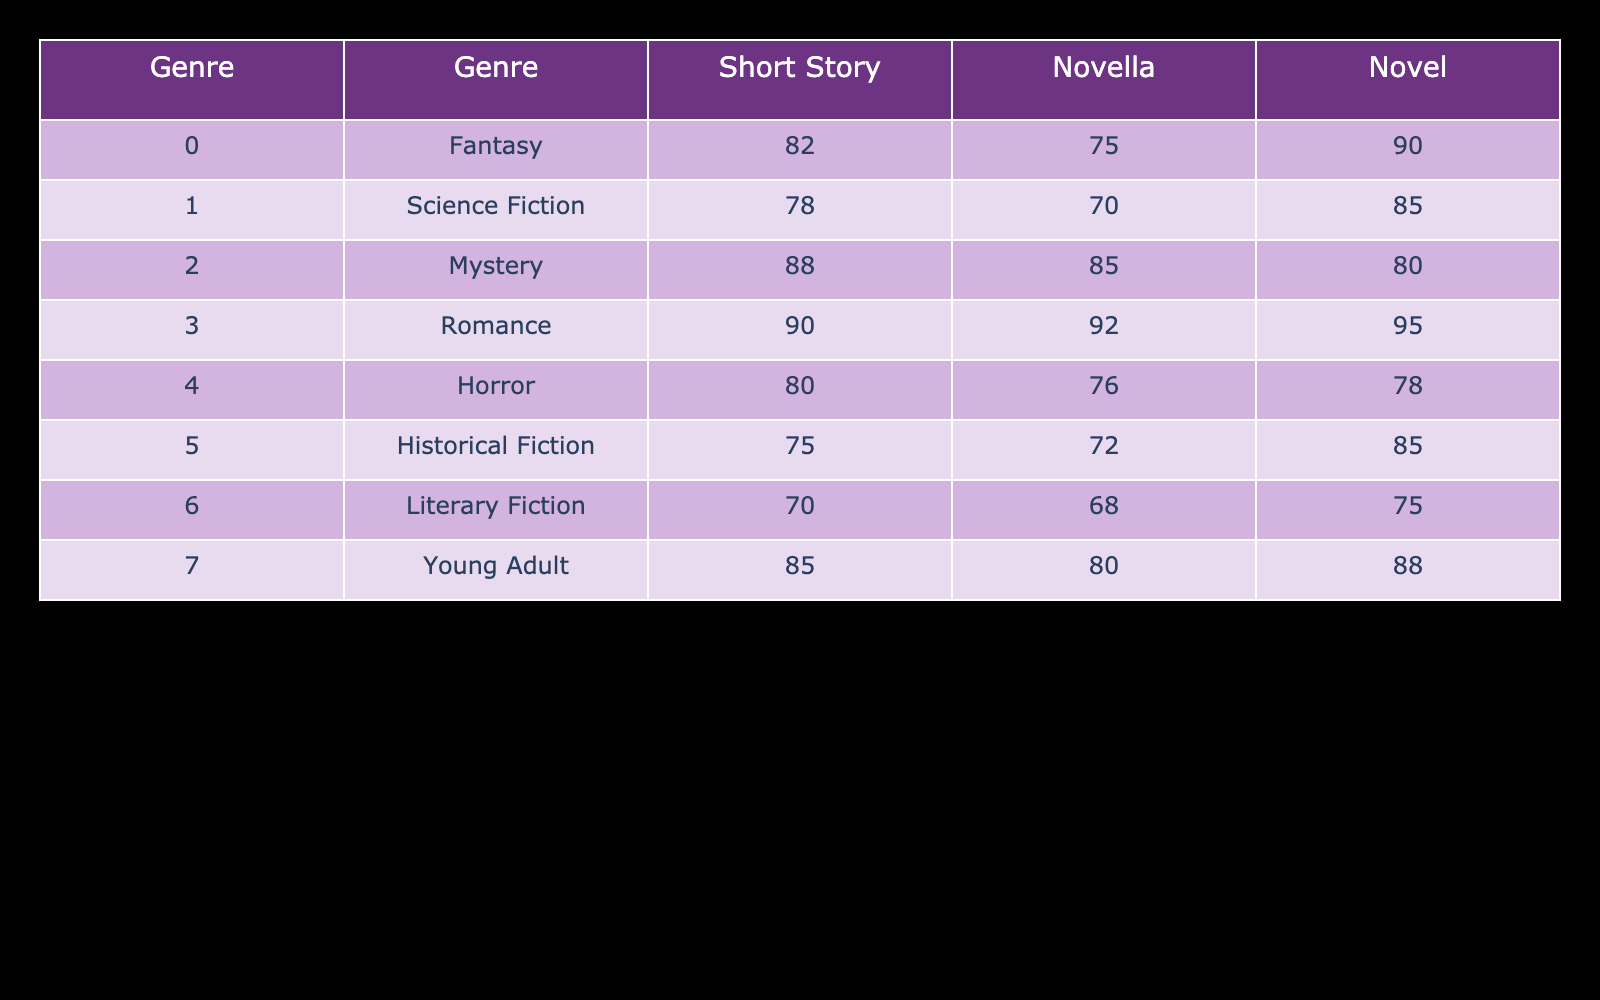What is the highest engagement level for the Romance genre? The table shows that for the Romance genre, the highest engagement level is 95 for Novels.
Answer: 95 Which story format has the lowest engagement level in the Literary Fiction genre? In the Literary Fiction genre, the story format with the lowest engagement level is Short Story, which has a value of 70.
Answer: 70 What is the average engagement level for Short Stories across all genres? To find the average engagement level for Short Stories, we sum the values: 82 + 78 + 88 + 90 + 80 + 75 + 70 + 85 = 478. There are 8 genres, so the average is 478/8 = 59.75.
Answer: 59.75 Is the engagement level for Novellas in Horror higher than in Historical Fiction? The engagement level for Novellas in Horror is 76 while in Historical Fiction it is 72. Since 76 > 72, the statement is true.
Answer: Yes What is the total engagement level for Science Fiction across all story formats? The engagement levels for Science Fiction are 78 (Short Story), 70 (Novella), and 85 (Novel). Adding these gives 78 + 70 + 85 = 233.
Answer: 233 What genre has the largest engagement difference between Novella and Novel formats? We will calculate the differences: Fantasy (75 - 90 = -15), Science Fiction (70 - 85 = -15), Mystery (85 - 80 = 5), Romance (92 - 95 = -3), Horror (76 - 78 = -2), Historical Fiction (72 - 85 = -13), Literary Fiction (68 - 75 = -7), Young Adult (80 - 88 = -8). The largest difference in absolute value is from Fantasy and Science Fiction with a difference of 15.
Answer: Fantasy and Science Fiction For which genre is the engagement level for Short Stories greater than 85? The genres with Short Story engagement levels greater than 85 are Romance (90) and Mystery (88). Both meet the requirement.
Answer: Romance and Mystery Which story format has the highest engagement overall? To find the highest overall engagement, we compare the values in each column: Short Stories max is 90 (Romance), Novellas max is 92 (Romance), and Novels max is 95 (Romance). Since 95 is the highest, Novels has the highest overall engagement.
Answer: Novels 